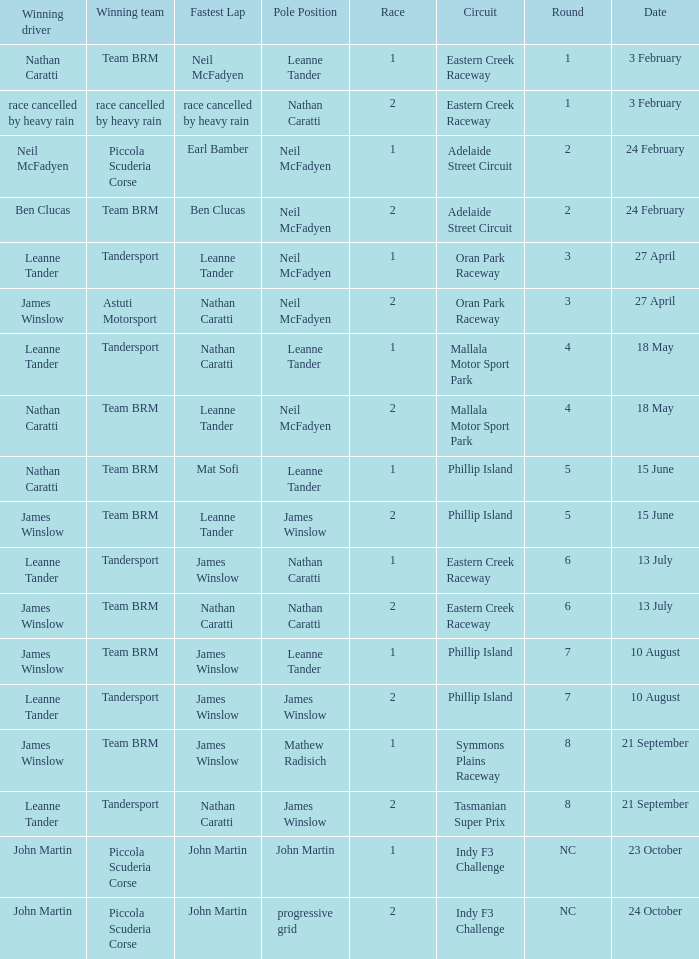Which race number in the Indy F3 Challenge circuit had John Martin in pole position? 1.0. 